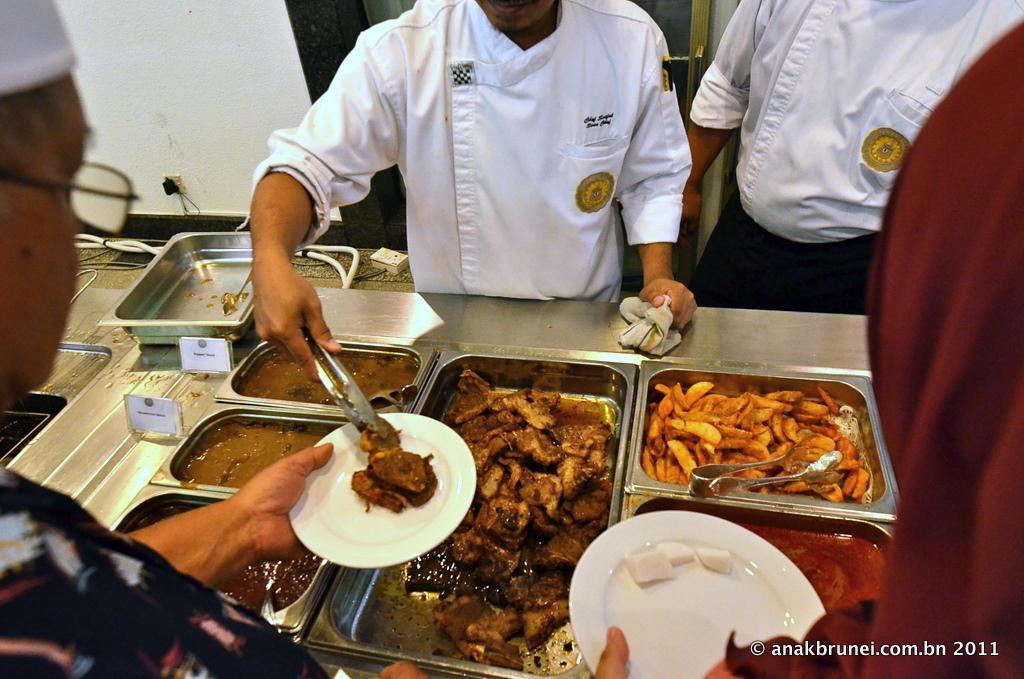Describe this image in one or two sentences. In this image we can see the food in steel containers. And we can see one person serving food. 